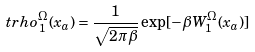Convert formula to latex. <formula><loc_0><loc_0><loc_500><loc_500>\ t r h o _ { 1 } ^ { \Omega } ( x _ { a } ) = \frac { 1 } { \sqrt { 2 \pi \beta } } \exp [ - \beta W ^ { \Omega } _ { 1 } ( x _ { a } ) ]</formula> 